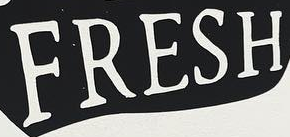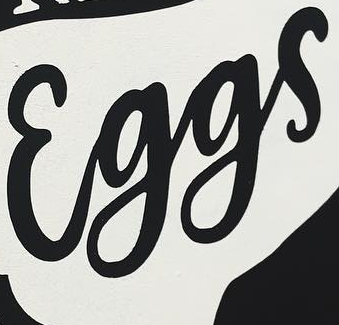Read the text from these images in sequence, separated by a semicolon. FRESH; Eggs 